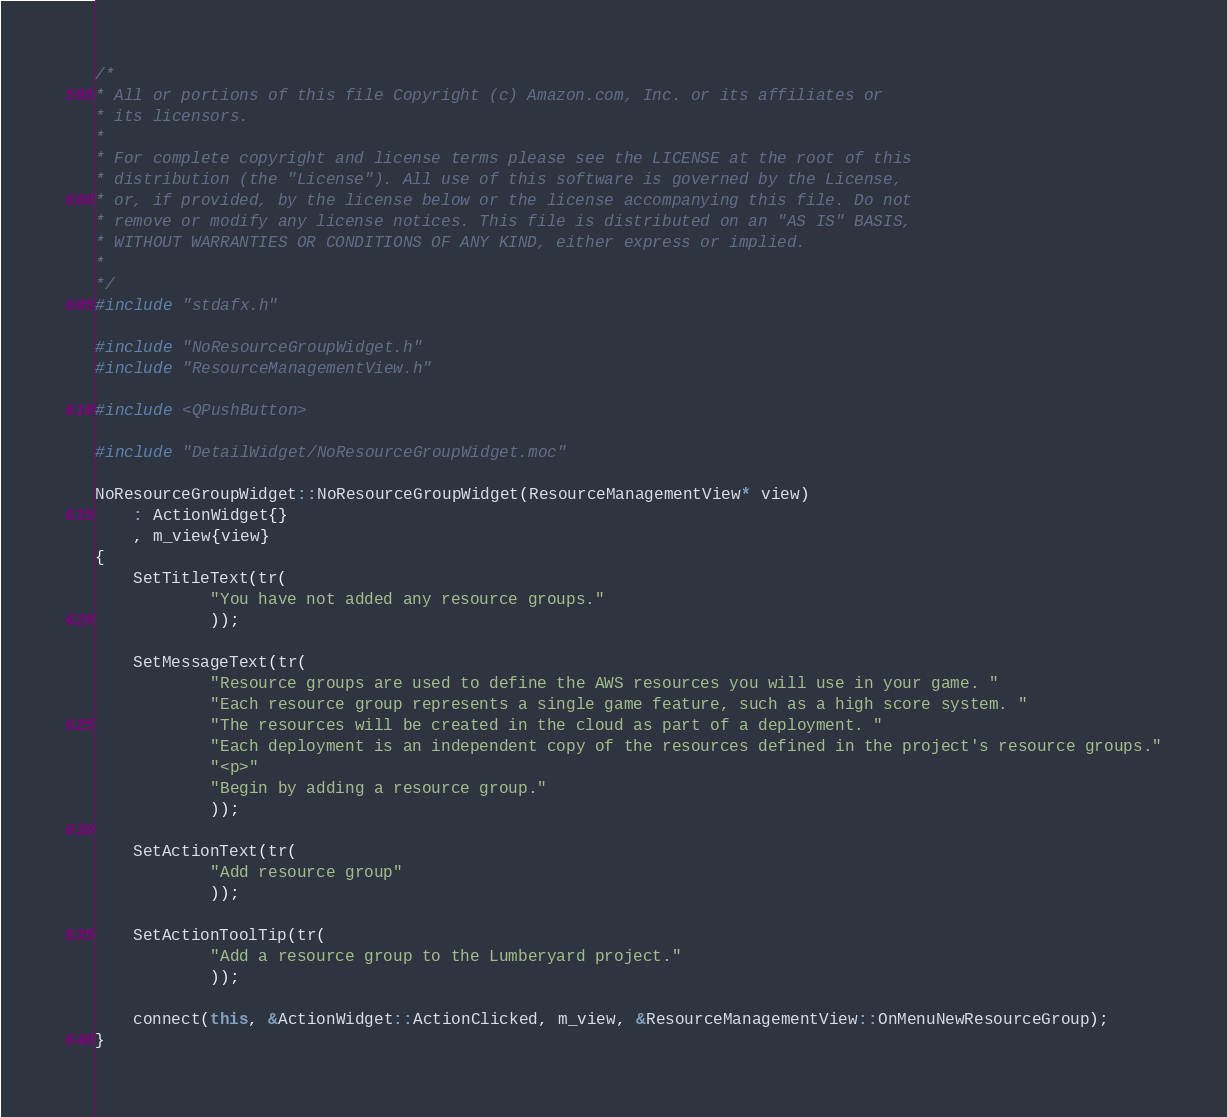<code> <loc_0><loc_0><loc_500><loc_500><_C++_>/*
* All or portions of this file Copyright (c) Amazon.com, Inc. or its affiliates or
* its licensors.
*
* For complete copyright and license terms please see the LICENSE at the root of this
* distribution (the "License"). All use of this software is governed by the License,
* or, if provided, by the license below or the license accompanying this file. Do not
* remove or modify any license notices. This file is distributed on an "AS IS" BASIS,
* WITHOUT WARRANTIES OR CONDITIONS OF ANY KIND, either express or implied.
*
*/
#include "stdafx.h"

#include "NoResourceGroupWidget.h"
#include "ResourceManagementView.h"

#include <QPushButton>

#include "DetailWidget/NoResourceGroupWidget.moc"

NoResourceGroupWidget::NoResourceGroupWidget(ResourceManagementView* view)
    : ActionWidget{}
    , m_view{view}
{
    SetTitleText(tr(
            "You have not added any resource groups."
            ));

    SetMessageText(tr(
            "Resource groups are used to define the AWS resources you will use in your game. "
            "Each resource group represents a single game feature, such as a high score system. "
            "The resources will be created in the cloud as part of a deployment. "
            "Each deployment is an independent copy of the resources defined in the project's resource groups."
            "<p>"
            "Begin by adding a resource group."
            ));

    SetActionText(tr(
            "Add resource group"
            ));

    SetActionToolTip(tr(
            "Add a resource group to the Lumberyard project."
            ));

    connect(this, &ActionWidget::ActionClicked, m_view, &ResourceManagementView::OnMenuNewResourceGroup);
}

</code> 